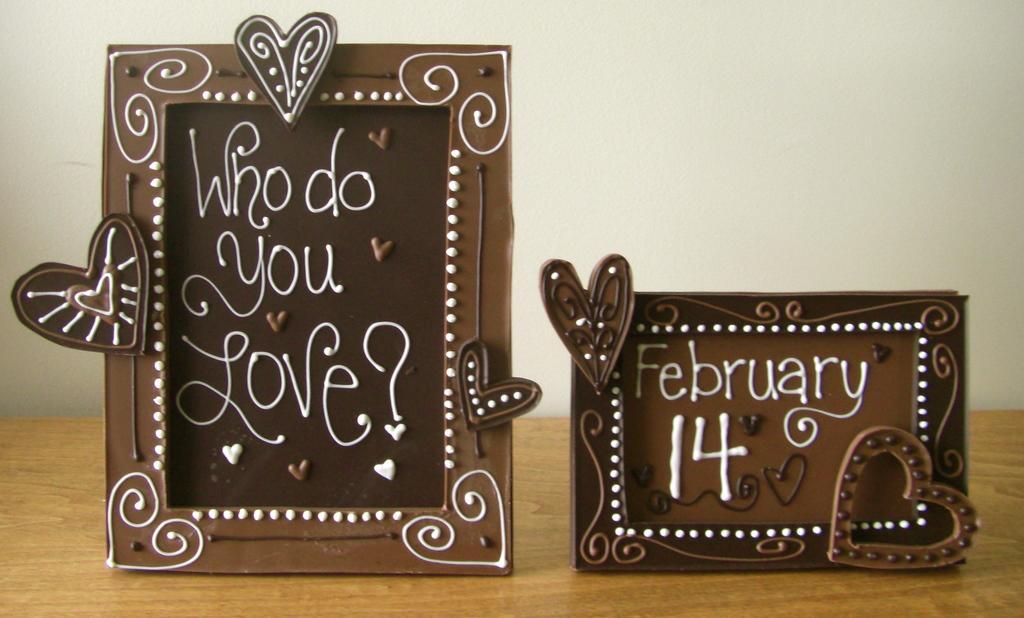Could you give a brief overview of what you see in this image? The picture I can see two brown color frames on which I can see some text is written is placed on the wooden surface. In the background, I can see the wall. 